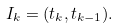<formula> <loc_0><loc_0><loc_500><loc_500>I _ { k } = ( t _ { k } , t _ { k - 1 } ) .</formula> 